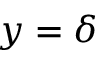<formula> <loc_0><loc_0><loc_500><loc_500>y = \delta</formula> 